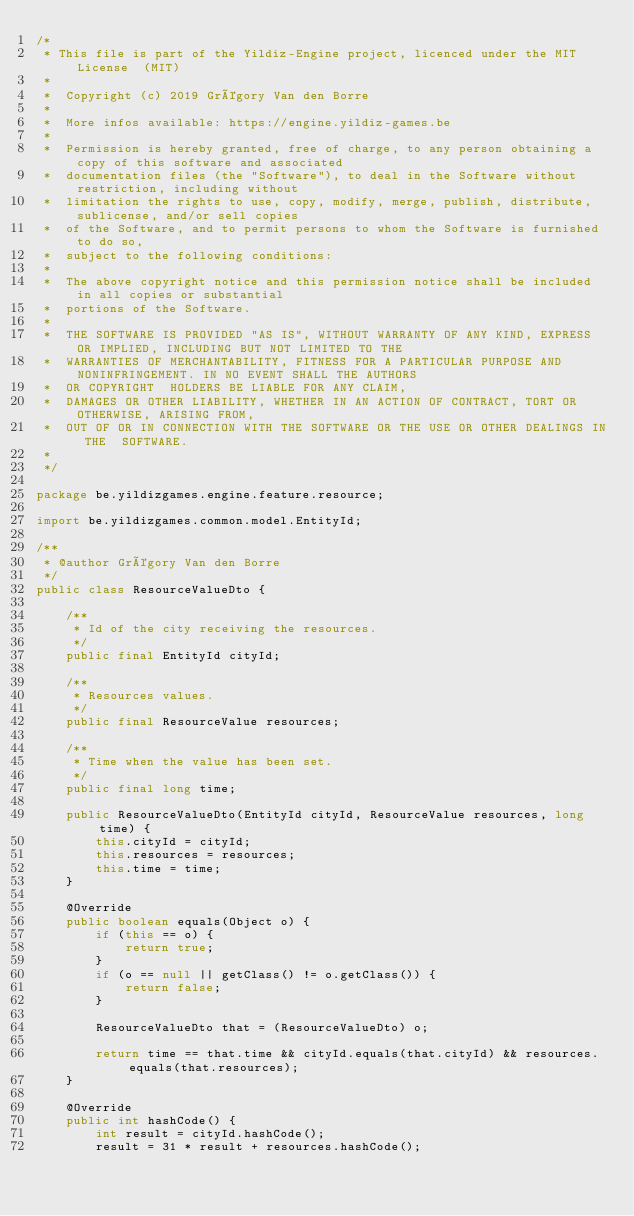Convert code to text. <code><loc_0><loc_0><loc_500><loc_500><_Java_>/*
 * This file is part of the Yildiz-Engine project, licenced under the MIT License  (MIT)
 *
 *  Copyright (c) 2019 Grégory Van den Borre
 *
 *  More infos available: https://engine.yildiz-games.be
 *
 *  Permission is hereby granted, free of charge, to any person obtaining a copy of this software and associated
 *  documentation files (the "Software"), to deal in the Software without restriction, including without
 *  limitation the rights to use, copy, modify, merge, publish, distribute, sublicense, and/or sell copies
 *  of the Software, and to permit persons to whom the Software is furnished to do so,
 *  subject to the following conditions:
 *
 *  The above copyright notice and this permission notice shall be included in all copies or substantial
 *  portions of the Software.
 *
 *  THE SOFTWARE IS PROVIDED "AS IS", WITHOUT WARRANTY OF ANY KIND, EXPRESS OR IMPLIED, INCLUDING BUT NOT LIMITED TO THE
 *  WARRANTIES OF MERCHANTABILITY, FITNESS FOR A PARTICULAR PURPOSE AND NONINFRINGEMENT. IN NO EVENT SHALL THE AUTHORS
 *  OR COPYRIGHT  HOLDERS BE LIABLE FOR ANY CLAIM,
 *  DAMAGES OR OTHER LIABILITY, WHETHER IN AN ACTION OF CONTRACT, TORT OR OTHERWISE, ARISING FROM,
 *  OUT OF OR IN CONNECTION WITH THE SOFTWARE OR THE USE OR OTHER DEALINGS IN THE  SOFTWARE.
 *
 */

package be.yildizgames.engine.feature.resource;

import be.yildizgames.common.model.EntityId;

/**
 * @author Grégory Van den Borre
 */
public class ResourceValueDto {

    /**
     * Id of the city receiving the resources.
     */
    public final EntityId cityId;

    /**
     * Resources values.
     */
    public final ResourceValue resources;

    /**
     * Time when the value has been set.
     */
    public final long time;

    public ResourceValueDto(EntityId cityId, ResourceValue resources, long time) {
        this.cityId = cityId;
        this.resources = resources;
        this.time = time;
    }

    @Override
    public boolean equals(Object o) {
        if (this == o) {
            return true;
        }
        if (o == null || getClass() != o.getClass()) {
            return false;
        }

        ResourceValueDto that = (ResourceValueDto) o;

        return time == that.time && cityId.equals(that.cityId) && resources.equals(that.resources);
    }

    @Override
    public int hashCode() {
        int result = cityId.hashCode();
        result = 31 * result + resources.hashCode();</code> 